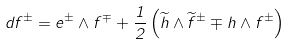Convert formula to latex. <formula><loc_0><loc_0><loc_500><loc_500>d f ^ { \pm } = e ^ { \pm } \wedge f ^ { \mp } + \frac { 1 } { 2 } \left ( \widetilde { h } \wedge \widetilde { f } ^ { \pm } \mp h \wedge f ^ { \pm } \right )</formula> 